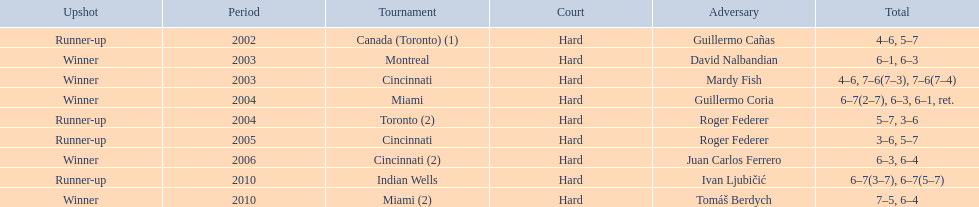How many championships occurred in toronto or montreal? 3. I'm looking to parse the entire table for insights. Could you assist me with that? {'header': ['Upshot', 'Period', 'Tournament', 'Court', 'Adversary', 'Total'], 'rows': [['Runner-up', '2002', 'Canada (Toronto) (1)', 'Hard', 'Guillermo Cañas', '4–6, 5–7'], ['Winner', '2003', 'Montreal', 'Hard', 'David Nalbandian', '6–1, 6–3'], ['Winner', '2003', 'Cincinnati', 'Hard', 'Mardy Fish', '4–6, 7–6(7–3), 7–6(7–4)'], ['Winner', '2004', 'Miami', 'Hard', 'Guillermo Coria', '6–7(2–7), 6–3, 6–1, ret.'], ['Runner-up', '2004', 'Toronto (2)', 'Hard', 'Roger Federer', '5–7, 3–6'], ['Runner-up', '2005', 'Cincinnati', 'Hard', 'Roger Federer', '3–6, 5–7'], ['Winner', '2006', 'Cincinnati (2)', 'Hard', 'Juan Carlos Ferrero', '6–3, 6–4'], ['Runner-up', '2010', 'Indian Wells', 'Hard', 'Ivan Ljubičić', '6–7(3–7), 6–7(5–7)'], ['Winner', '2010', 'Miami (2)', 'Hard', 'Tomáš Berdych', '7–5, 6–4']]} 